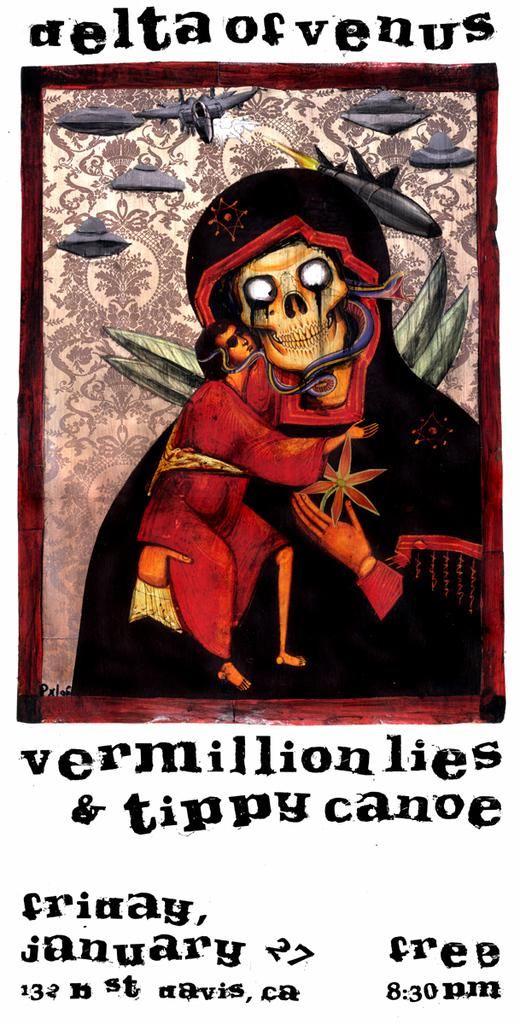<image>
Relay a brief, clear account of the picture shown. A poster advertising a show of Vermillion Lies and Tippy Canoe show a free event. 